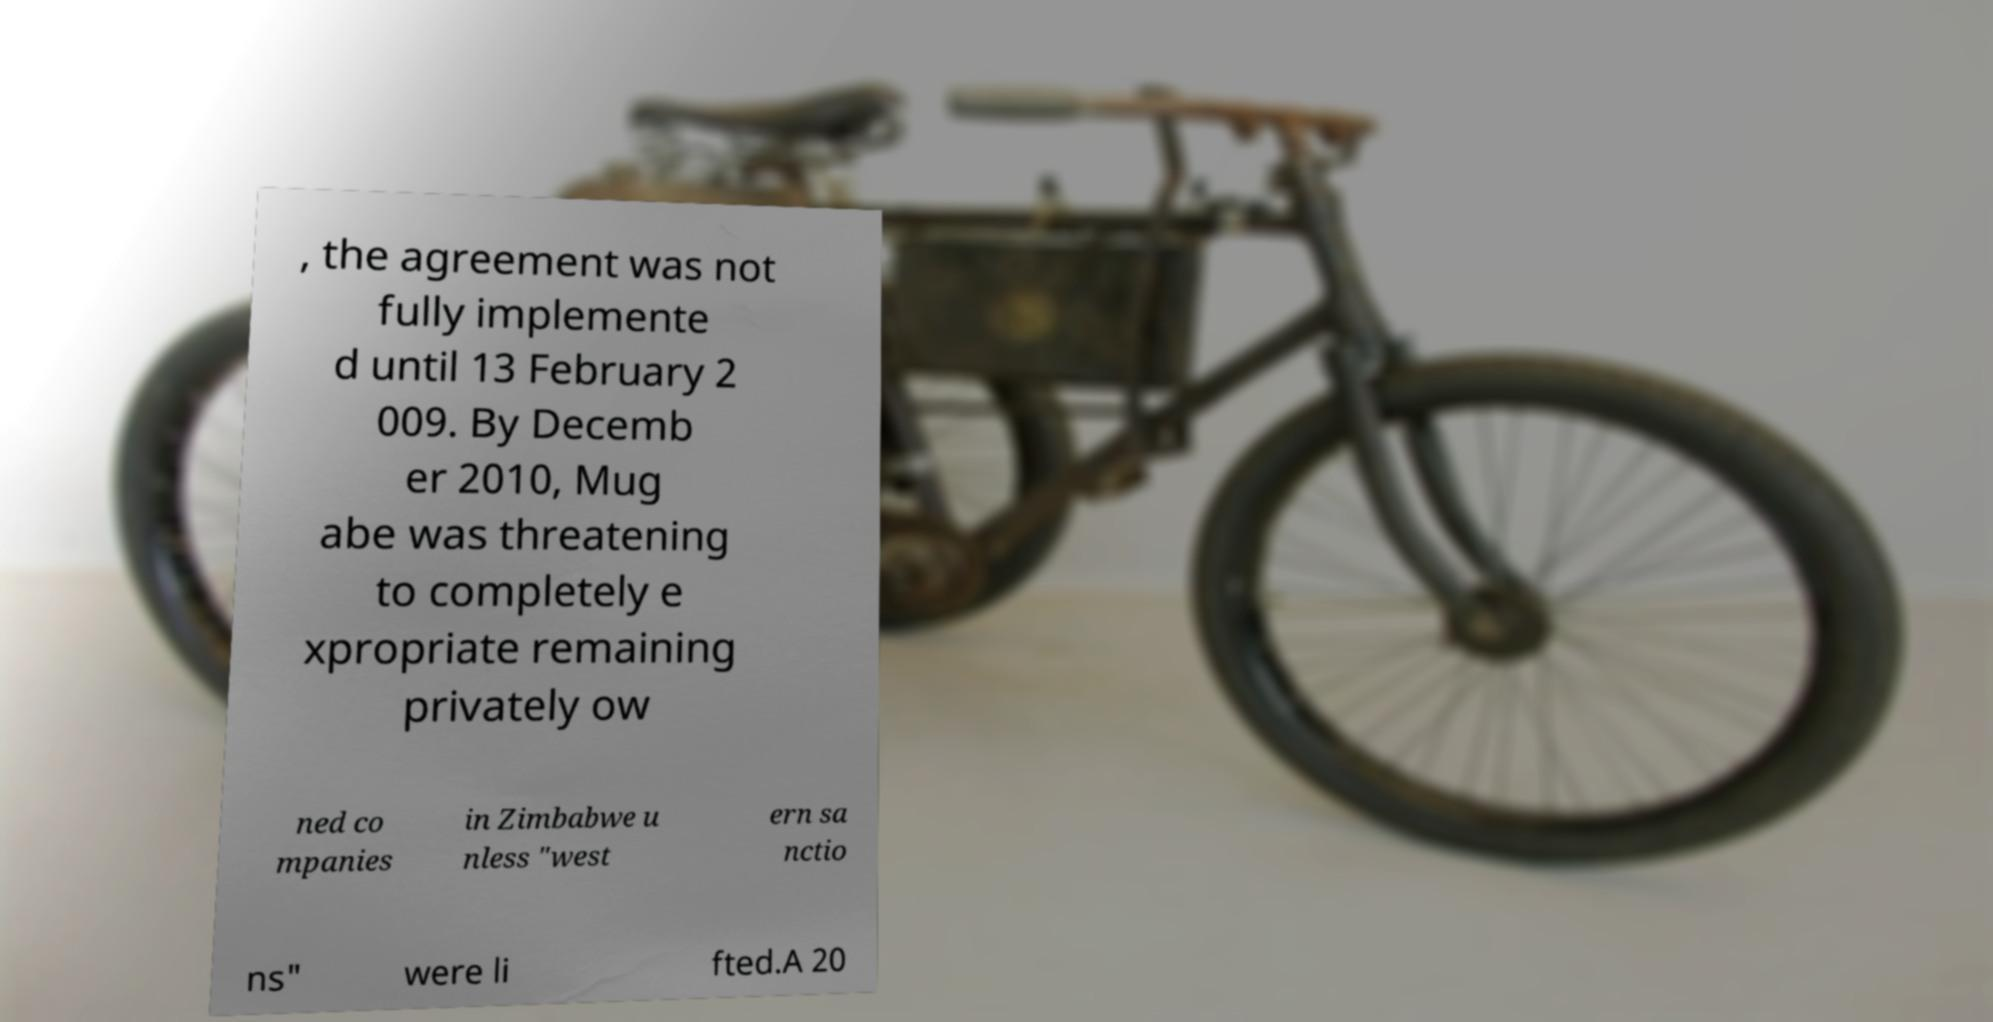Can you read and provide the text displayed in the image?This photo seems to have some interesting text. Can you extract and type it out for me? , the agreement was not fully implemente d until 13 February 2 009. By Decemb er 2010, Mug abe was threatening to completely e xpropriate remaining privately ow ned co mpanies in Zimbabwe u nless "west ern sa nctio ns" were li fted.A 20 